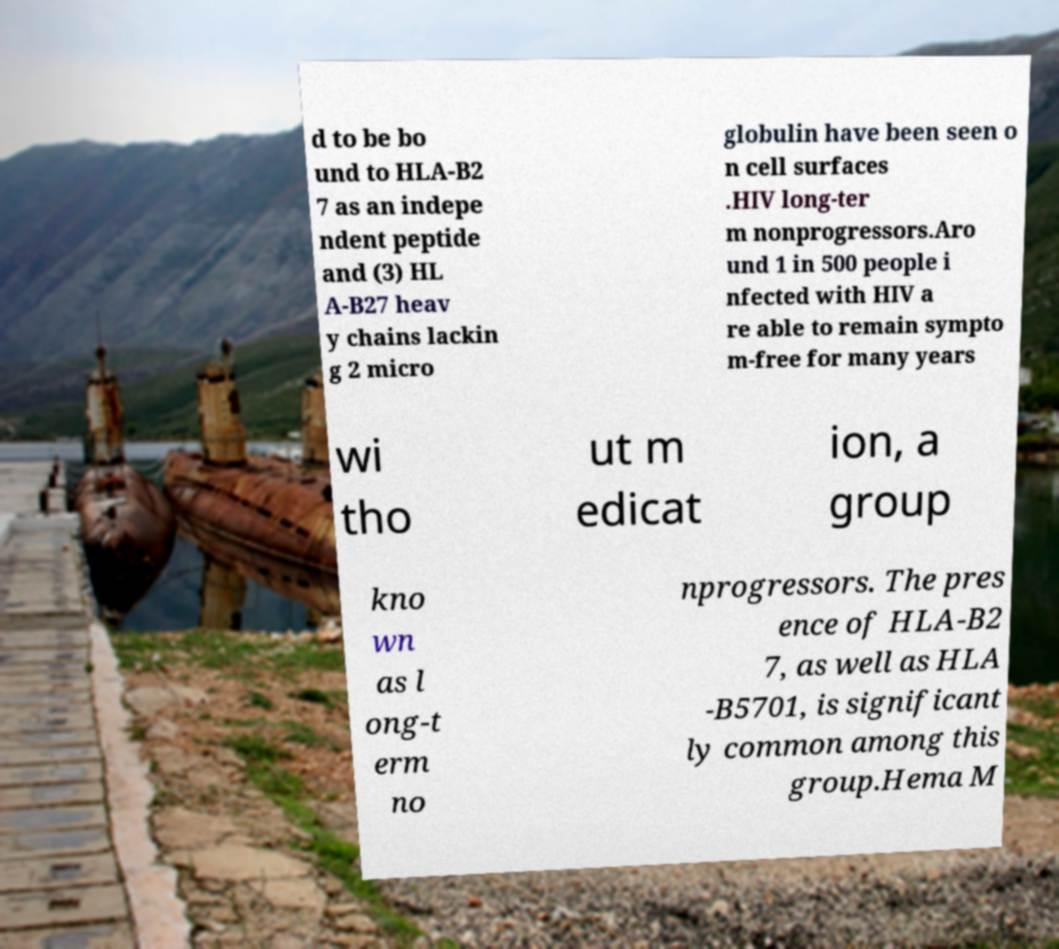Could you extract and type out the text from this image? d to be bo und to HLA-B2 7 as an indepe ndent peptide and (3) HL A-B27 heav y chains lackin g 2 micro globulin have been seen o n cell surfaces .HIV long-ter m nonprogressors.Aro und 1 in 500 people i nfected with HIV a re able to remain sympto m-free for many years wi tho ut m edicat ion, a group kno wn as l ong-t erm no nprogressors. The pres ence of HLA-B2 7, as well as HLA -B5701, is significant ly common among this group.Hema M 